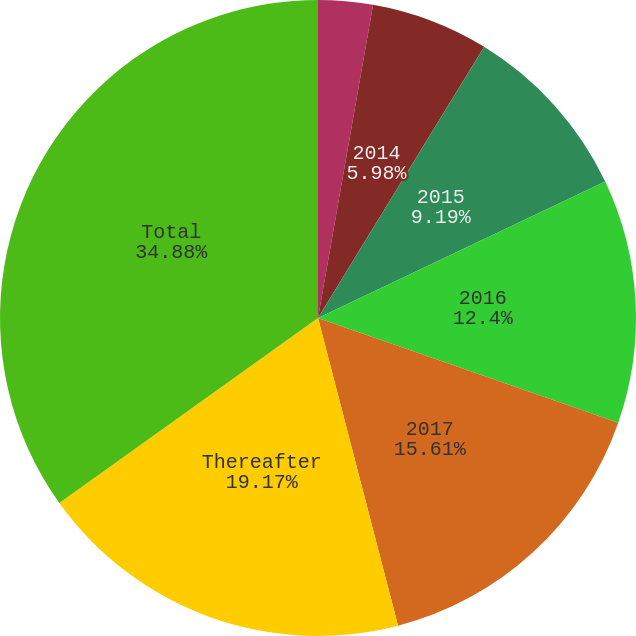Convert chart. <chart><loc_0><loc_0><loc_500><loc_500><pie_chart><fcel>2013<fcel>2014<fcel>2015<fcel>2016<fcel>2017<fcel>Thereafter<fcel>Total<nl><fcel>2.77%<fcel>5.98%<fcel>9.19%<fcel>12.4%<fcel>15.61%<fcel>19.17%<fcel>34.88%<nl></chart> 